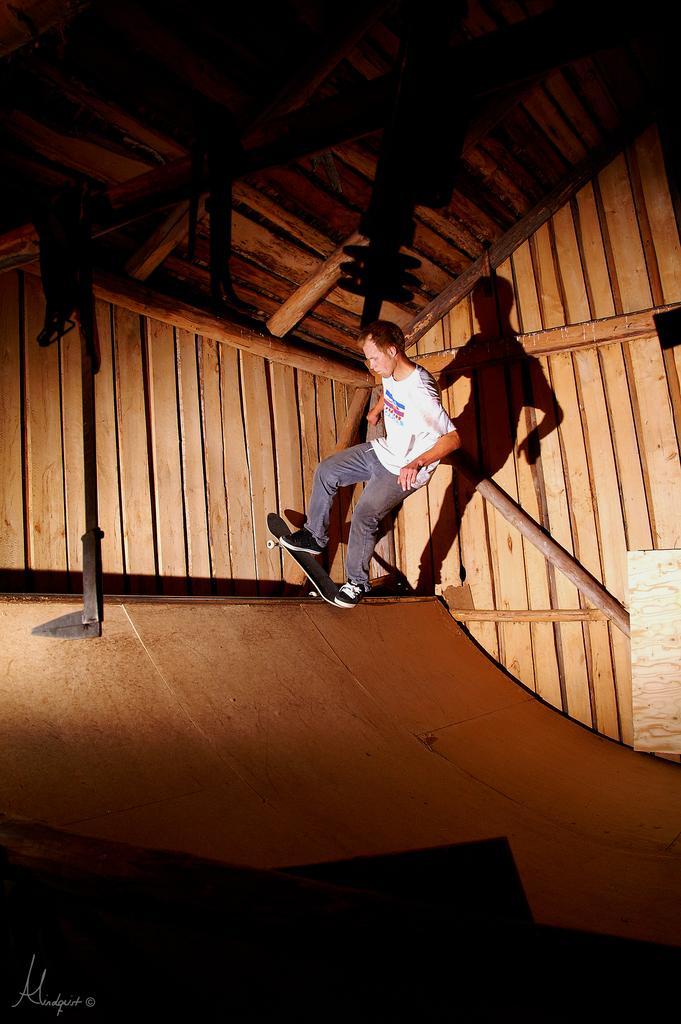Describe this image in one or two sentences. This image consists of a man skating. At the bottom, there is a ramp. In the background, there are walls made up of wood. 